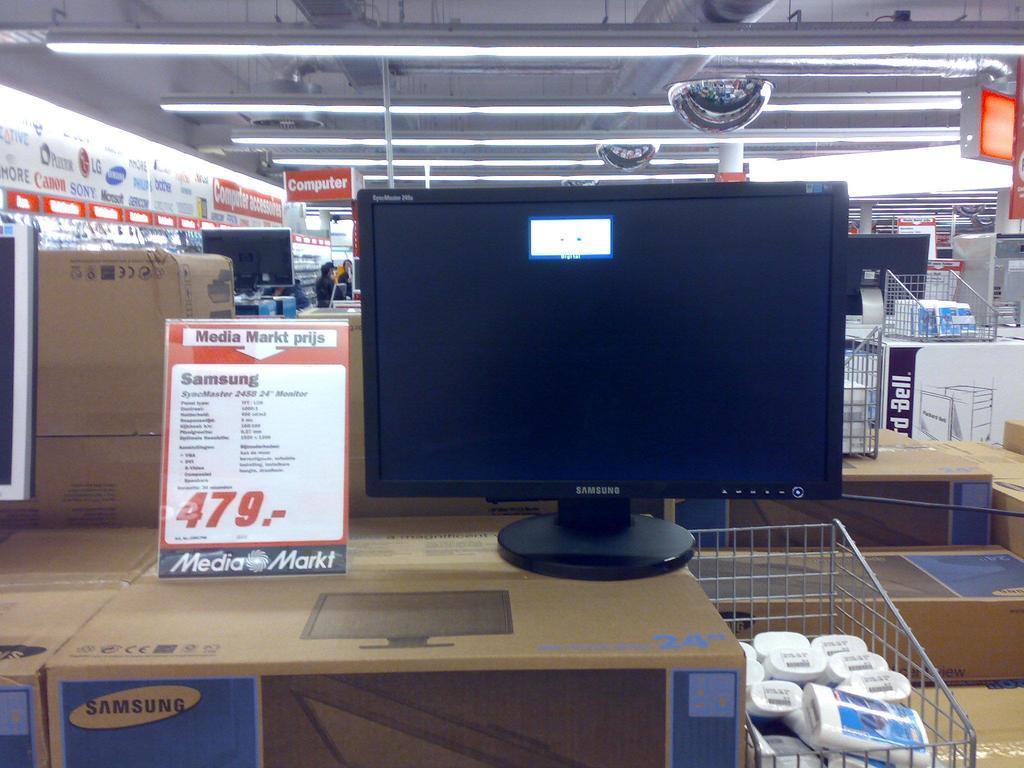Please provide a concise description of this image. In the picture I can see a desktop placed on a wooden box and there is a paper which has something written on it and there are few objects which is placed in a trolley and there are few wooden boxes and some other objects in the background. 